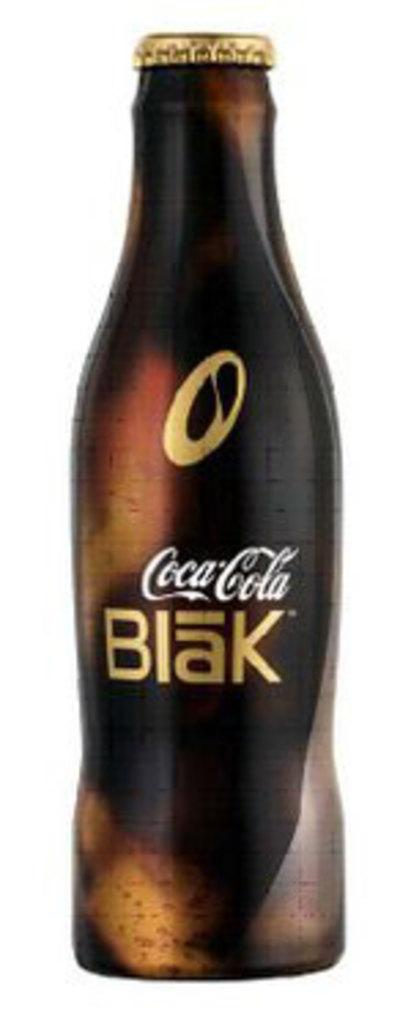<image>
Summarize the visual content of the image. A glass bottle of the drink Coca Cola Blak 